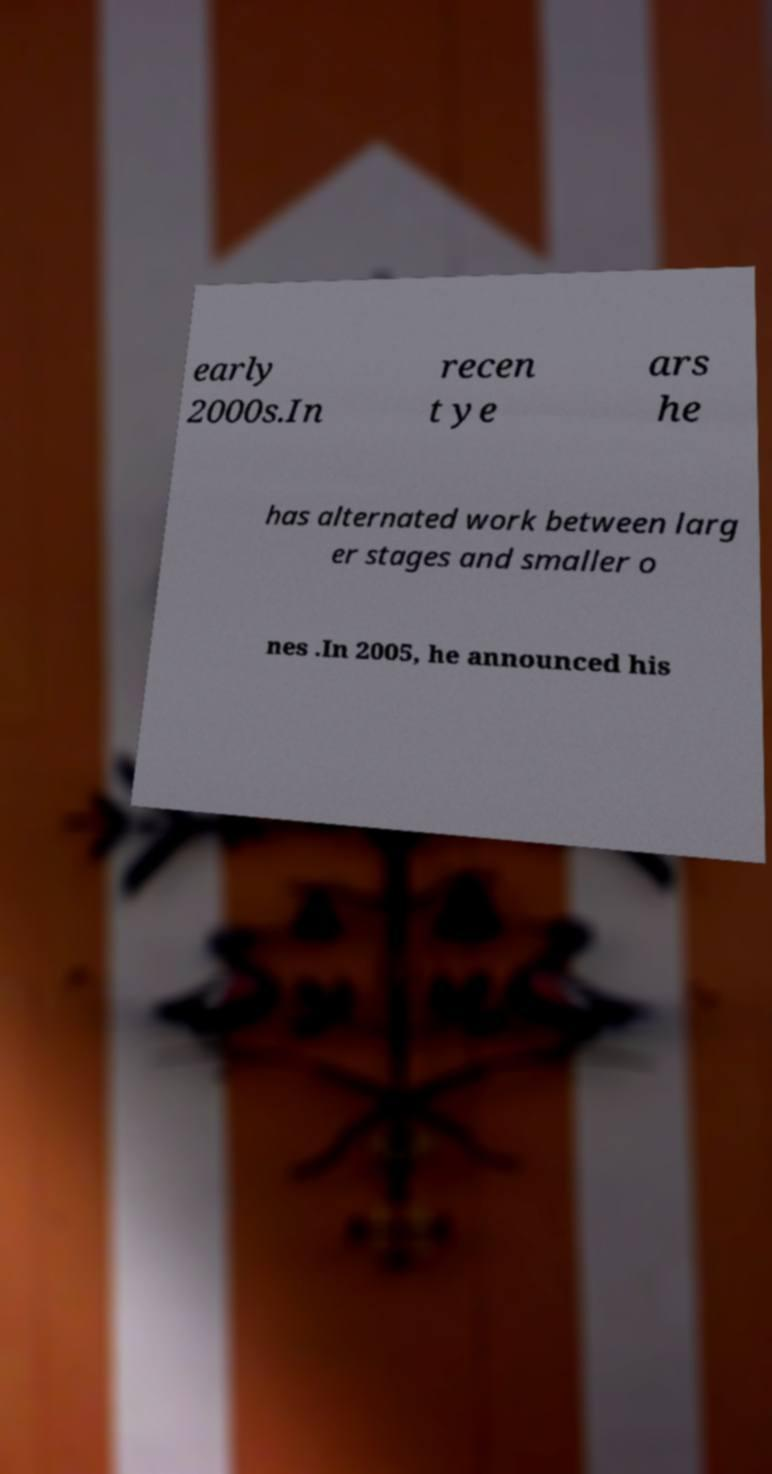Can you read and provide the text displayed in the image?This photo seems to have some interesting text. Can you extract and type it out for me? early 2000s.In recen t ye ars he has alternated work between larg er stages and smaller o nes .In 2005, he announced his 